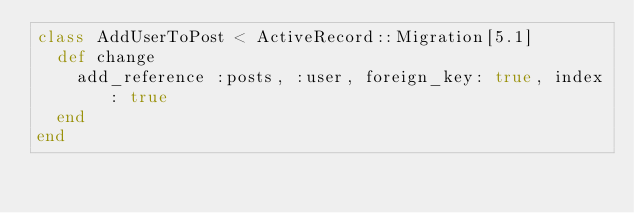Convert code to text. <code><loc_0><loc_0><loc_500><loc_500><_Ruby_>class AddUserToPost < ActiveRecord::Migration[5.1]
  def change
    add_reference :posts, :user, foreign_key: true, index: true
  end
end
</code> 